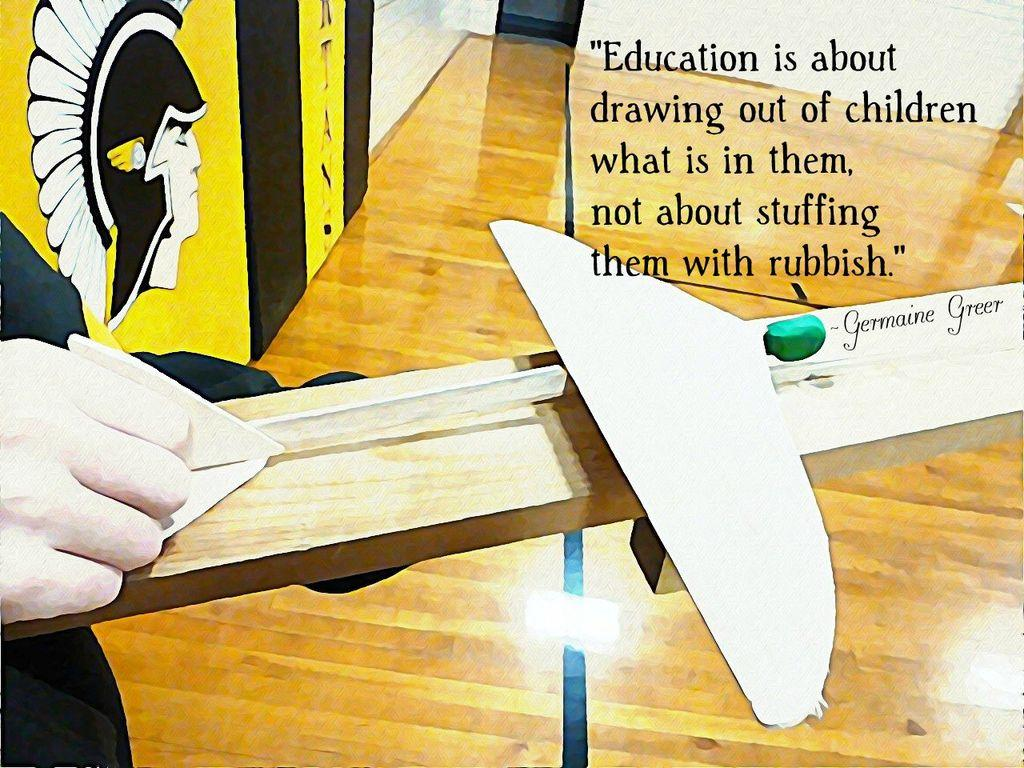<image>
Provide a brief description of the given image. a plane is being held by a hand with a sign that says Education is about drawing out of children ...... 